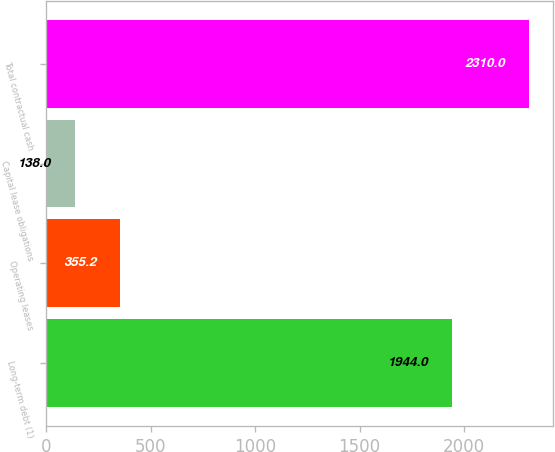Convert chart. <chart><loc_0><loc_0><loc_500><loc_500><bar_chart><fcel>Long-term debt (1)<fcel>Operating leases<fcel>Capital lease obligations<fcel>Total contractual cash<nl><fcel>1944<fcel>355.2<fcel>138<fcel>2310<nl></chart> 